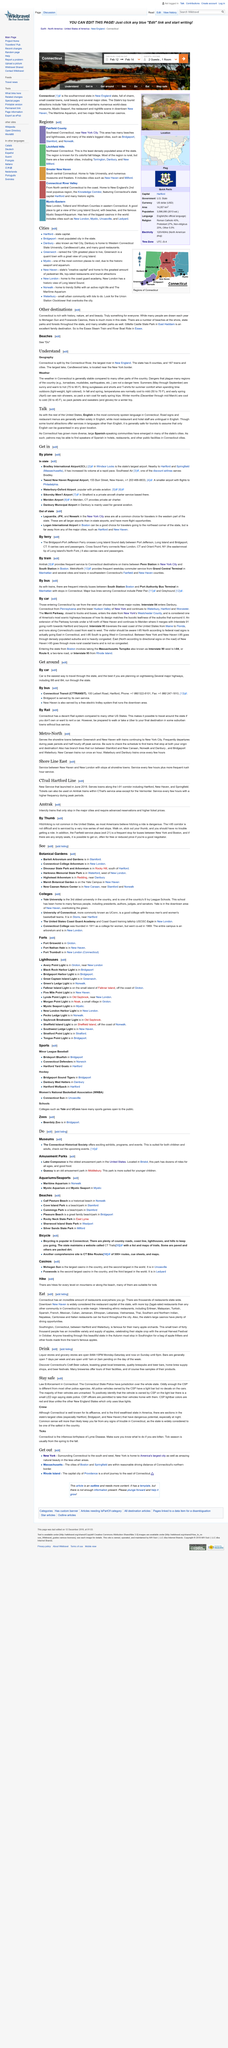Specify some key components in this picture. English is the most commonly spoken language in Connecticut, just as it is in the rest of the United States. Connecticut has seen an increase in diversity, with the emergence of large Spanish speaking communities in many of its cities. As a result, there are now Spanish speaking communities in Connecticut. The Merritt Parkway is closed to trucks and buses. In Connecticut, there are potentially dangerous spots in Hartford, Bridgeport, and New Haven. The Connecticut River is the largest river in New England. 